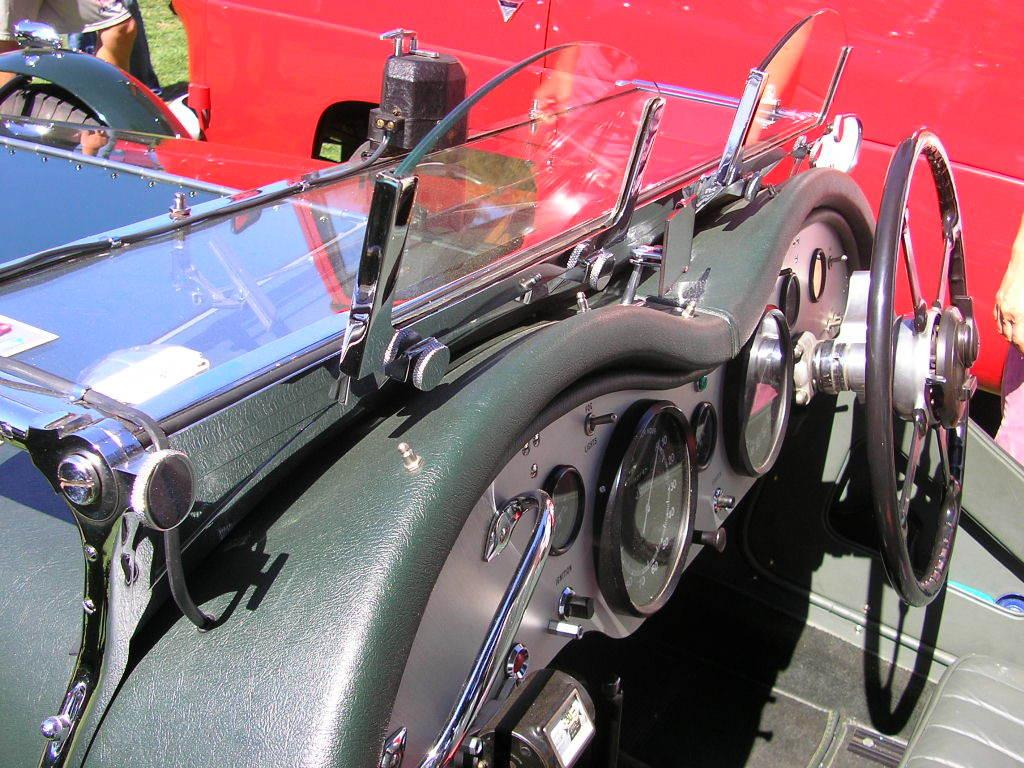What type of objects can be seen in the image? There are vehicles in the image. Can you describe any part of a person in the image? A person's legs are visible in the image. What is a specific feature of one of the vehicles? There is a steering wheel in the image. What other objects can be seen in the image besides the vehicles and the person's legs? There are other objects present in the image. What color is the silver top in the image? There is no silver top present in the image. 